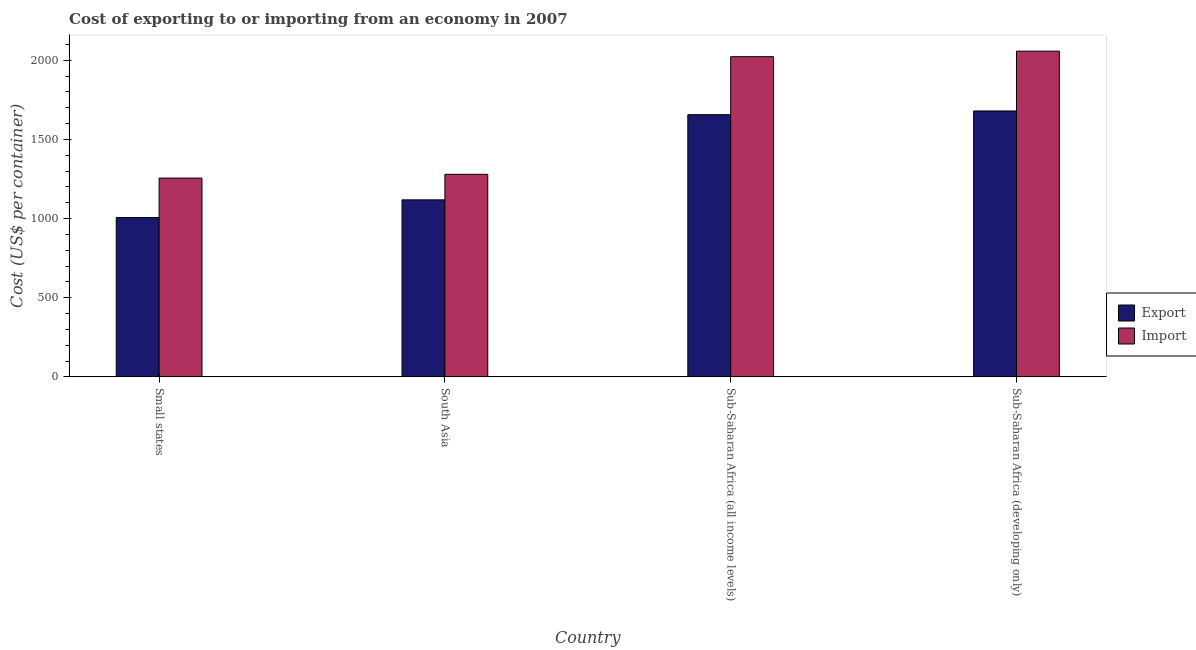Are the number of bars per tick equal to the number of legend labels?
Provide a short and direct response. Yes. Are the number of bars on each tick of the X-axis equal?
Provide a short and direct response. Yes. How many bars are there on the 4th tick from the right?
Offer a very short reply. 2. What is the label of the 1st group of bars from the left?
Make the answer very short. Small states. What is the export cost in Small states?
Offer a very short reply. 1006.28. Across all countries, what is the maximum import cost?
Make the answer very short. 2057.07. Across all countries, what is the minimum import cost?
Ensure brevity in your answer.  1255.44. In which country was the export cost maximum?
Keep it short and to the point. Sub-Saharan Africa (developing only). In which country was the export cost minimum?
Provide a succinct answer. Small states. What is the total export cost in the graph?
Offer a very short reply. 5459.54. What is the difference between the import cost in Small states and that in Sub-Saharan Africa (all income levels)?
Make the answer very short. -766.69. What is the difference between the export cost in Sub-Saharan Africa (all income levels) and the import cost in Sub-Saharan Africa (developing only)?
Give a very brief answer. -401.18. What is the average import cost per country?
Your answer should be very brief. 1653.5. What is the difference between the export cost and import cost in South Asia?
Provide a short and direct response. -161.38. In how many countries, is the export cost greater than 1900 US$?
Your response must be concise. 0. What is the ratio of the export cost in South Asia to that in Sub-Saharan Africa (all income levels)?
Your response must be concise. 0.68. Is the export cost in South Asia less than that in Sub-Saharan Africa (developing only)?
Offer a terse response. Yes. What is the difference between the highest and the second highest export cost?
Your answer should be compact. 23.47. What is the difference between the highest and the lowest import cost?
Your answer should be compact. 801.63. In how many countries, is the export cost greater than the average export cost taken over all countries?
Ensure brevity in your answer.  2. Is the sum of the export cost in South Asia and Sub-Saharan Africa (all income levels) greater than the maximum import cost across all countries?
Your answer should be very brief. Yes. What does the 1st bar from the left in South Asia represents?
Your response must be concise. Export. What does the 1st bar from the right in Small states represents?
Your answer should be very brief. Import. Are all the bars in the graph horizontal?
Your answer should be compact. No. How many countries are there in the graph?
Your answer should be compact. 4. What is the difference between two consecutive major ticks on the Y-axis?
Your answer should be compact. 500. Are the values on the major ticks of Y-axis written in scientific E-notation?
Your response must be concise. No. Does the graph contain any zero values?
Your answer should be compact. No. Does the graph contain grids?
Provide a short and direct response. No. What is the title of the graph?
Provide a short and direct response. Cost of exporting to or importing from an economy in 2007. What is the label or title of the X-axis?
Your response must be concise. Country. What is the label or title of the Y-axis?
Provide a succinct answer. Cost (US$ per container). What is the Cost (US$ per container) in Export in Small states?
Your answer should be compact. 1006.28. What is the Cost (US$ per container) in Import in Small states?
Your answer should be compact. 1255.44. What is the Cost (US$ per container) in Export in South Asia?
Make the answer very short. 1118. What is the Cost (US$ per container) of Import in South Asia?
Keep it short and to the point. 1279.38. What is the Cost (US$ per container) of Export in Sub-Saharan Africa (all income levels)?
Provide a succinct answer. 1655.89. What is the Cost (US$ per container) of Import in Sub-Saharan Africa (all income levels)?
Provide a short and direct response. 2022.13. What is the Cost (US$ per container) in Export in Sub-Saharan Africa (developing only)?
Ensure brevity in your answer.  1679.36. What is the Cost (US$ per container) of Import in Sub-Saharan Africa (developing only)?
Your answer should be compact. 2057.07. Across all countries, what is the maximum Cost (US$ per container) of Export?
Provide a succinct answer. 1679.36. Across all countries, what is the maximum Cost (US$ per container) in Import?
Ensure brevity in your answer.  2057.07. Across all countries, what is the minimum Cost (US$ per container) in Export?
Provide a short and direct response. 1006.28. Across all countries, what is the minimum Cost (US$ per container) in Import?
Ensure brevity in your answer.  1255.44. What is the total Cost (US$ per container) of Export in the graph?
Provide a short and direct response. 5459.54. What is the total Cost (US$ per container) in Import in the graph?
Your response must be concise. 6614.01. What is the difference between the Cost (US$ per container) of Export in Small states and that in South Asia?
Give a very brief answer. -111.72. What is the difference between the Cost (US$ per container) of Import in Small states and that in South Asia?
Your response must be concise. -23.94. What is the difference between the Cost (US$ per container) of Export in Small states and that in Sub-Saharan Africa (all income levels)?
Offer a terse response. -649.61. What is the difference between the Cost (US$ per container) in Import in Small states and that in Sub-Saharan Africa (all income levels)?
Your response must be concise. -766.69. What is the difference between the Cost (US$ per container) in Export in Small states and that in Sub-Saharan Africa (developing only)?
Give a very brief answer. -673.08. What is the difference between the Cost (US$ per container) of Import in Small states and that in Sub-Saharan Africa (developing only)?
Make the answer very short. -801.63. What is the difference between the Cost (US$ per container) in Export in South Asia and that in Sub-Saharan Africa (all income levels)?
Offer a very short reply. -537.89. What is the difference between the Cost (US$ per container) of Import in South Asia and that in Sub-Saharan Africa (all income levels)?
Offer a very short reply. -742.76. What is the difference between the Cost (US$ per container) of Export in South Asia and that in Sub-Saharan Africa (developing only)?
Offer a terse response. -561.36. What is the difference between the Cost (US$ per container) of Import in South Asia and that in Sub-Saharan Africa (developing only)?
Ensure brevity in your answer.  -777.69. What is the difference between the Cost (US$ per container) in Export in Sub-Saharan Africa (all income levels) and that in Sub-Saharan Africa (developing only)?
Your answer should be compact. -23.47. What is the difference between the Cost (US$ per container) in Import in Sub-Saharan Africa (all income levels) and that in Sub-Saharan Africa (developing only)?
Your answer should be very brief. -34.94. What is the difference between the Cost (US$ per container) of Export in Small states and the Cost (US$ per container) of Import in South Asia?
Provide a succinct answer. -273.09. What is the difference between the Cost (US$ per container) in Export in Small states and the Cost (US$ per container) in Import in Sub-Saharan Africa (all income levels)?
Provide a short and direct response. -1015.85. What is the difference between the Cost (US$ per container) in Export in Small states and the Cost (US$ per container) in Import in Sub-Saharan Africa (developing only)?
Your answer should be very brief. -1050.79. What is the difference between the Cost (US$ per container) of Export in South Asia and the Cost (US$ per container) of Import in Sub-Saharan Africa (all income levels)?
Your response must be concise. -904.13. What is the difference between the Cost (US$ per container) of Export in South Asia and the Cost (US$ per container) of Import in Sub-Saharan Africa (developing only)?
Ensure brevity in your answer.  -939.07. What is the difference between the Cost (US$ per container) in Export in Sub-Saharan Africa (all income levels) and the Cost (US$ per container) in Import in Sub-Saharan Africa (developing only)?
Offer a terse response. -401.18. What is the average Cost (US$ per container) of Export per country?
Your answer should be very brief. 1364.88. What is the average Cost (US$ per container) of Import per country?
Provide a short and direct response. 1653.5. What is the difference between the Cost (US$ per container) of Export and Cost (US$ per container) of Import in Small states?
Your response must be concise. -249.15. What is the difference between the Cost (US$ per container) in Export and Cost (US$ per container) in Import in South Asia?
Your answer should be very brief. -161.38. What is the difference between the Cost (US$ per container) of Export and Cost (US$ per container) of Import in Sub-Saharan Africa (all income levels)?
Provide a succinct answer. -366.24. What is the difference between the Cost (US$ per container) of Export and Cost (US$ per container) of Import in Sub-Saharan Africa (developing only)?
Offer a terse response. -377.7. What is the ratio of the Cost (US$ per container) in Export in Small states to that in South Asia?
Your response must be concise. 0.9. What is the ratio of the Cost (US$ per container) in Import in Small states to that in South Asia?
Offer a very short reply. 0.98. What is the ratio of the Cost (US$ per container) of Export in Small states to that in Sub-Saharan Africa (all income levels)?
Your answer should be compact. 0.61. What is the ratio of the Cost (US$ per container) in Import in Small states to that in Sub-Saharan Africa (all income levels)?
Your response must be concise. 0.62. What is the ratio of the Cost (US$ per container) of Export in Small states to that in Sub-Saharan Africa (developing only)?
Make the answer very short. 0.6. What is the ratio of the Cost (US$ per container) in Import in Small states to that in Sub-Saharan Africa (developing only)?
Provide a short and direct response. 0.61. What is the ratio of the Cost (US$ per container) in Export in South Asia to that in Sub-Saharan Africa (all income levels)?
Provide a succinct answer. 0.68. What is the ratio of the Cost (US$ per container) of Import in South Asia to that in Sub-Saharan Africa (all income levels)?
Your answer should be compact. 0.63. What is the ratio of the Cost (US$ per container) in Export in South Asia to that in Sub-Saharan Africa (developing only)?
Offer a terse response. 0.67. What is the ratio of the Cost (US$ per container) of Import in South Asia to that in Sub-Saharan Africa (developing only)?
Offer a terse response. 0.62. What is the ratio of the Cost (US$ per container) in Import in Sub-Saharan Africa (all income levels) to that in Sub-Saharan Africa (developing only)?
Provide a succinct answer. 0.98. What is the difference between the highest and the second highest Cost (US$ per container) in Export?
Ensure brevity in your answer.  23.47. What is the difference between the highest and the second highest Cost (US$ per container) in Import?
Keep it short and to the point. 34.94. What is the difference between the highest and the lowest Cost (US$ per container) of Export?
Keep it short and to the point. 673.08. What is the difference between the highest and the lowest Cost (US$ per container) of Import?
Your answer should be very brief. 801.63. 